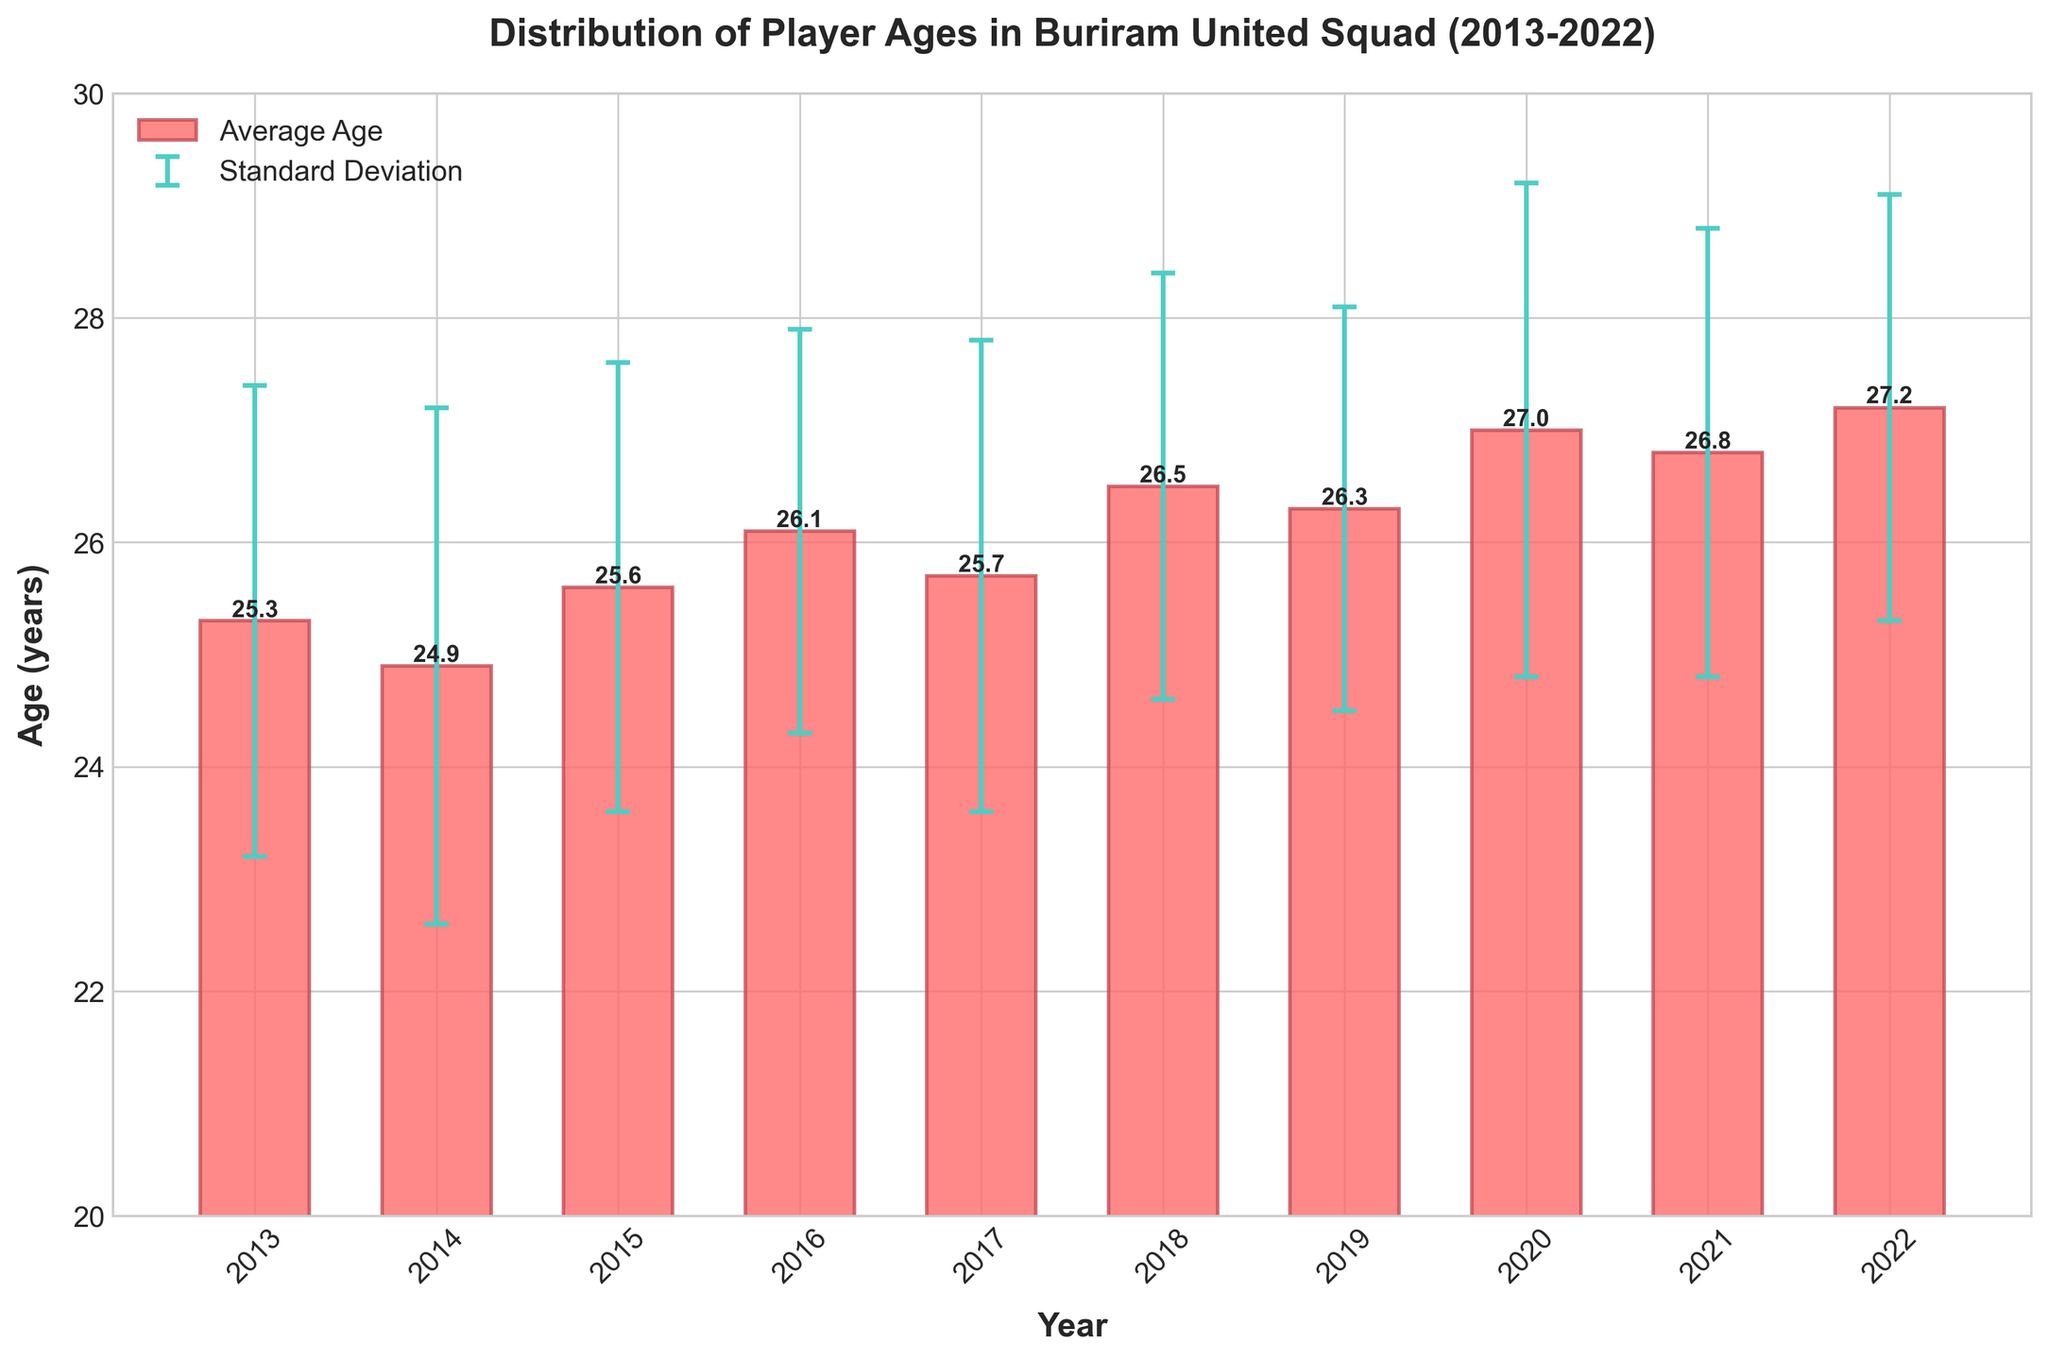what is the title of the chart? The title of the chart is usually located at the top of the figure. In this case, the title is "Distribution of Player Ages in Buriram United Squad (2013-2022)"
Answer: Distribution of Player Ages in Buriram United Squad (2013-2022) How many years are represented in the bar chart? To count the number of years, look at the x-axis labels. They range from 2013 to 2022, inclusive.
Answer: 10 What is the average age of players in 2017? Look for the bar corresponding to the year 2017. The height of the bar represents the average age, which is also labeled on top.
Answer: 25.7 During which year did the squad have the highest average age? Find the bar with the greatest height and look at which year it corresponds to. The highest bar is for 2022.
Answer: 2022 Which year shows the smallest standard deviation in player ages, and what is its value? The standard deviation is represented by the error bars. Look for the smallest error bar and identify the corresponding year and value. The smallest error bar is in 2019, with a value of 1.8.
Answer: 2019, 1.8 What is the difference between the average age in 2020 and 2013? Find the average ages for 2020 and 2013 from the bars and subtract the two values (27.0 - 25.3).
Answer: 1.7 Which year exhibits a higher average age, 2016 or 2018, and by how much? Compare the heights of the bars for 2016 and 2018. 2016 has an average age of 26.1, and 2018 has an average age of 26.5. The difference is 0.4.
Answer: 2018, by 0.4 Is the average age in 2015 closer to the average age in 2014 or 2016? Compare the differences (25.6 - 24.9 for 2014 and 26.1 - 25.6 for 2016). The difference between 2015 and 2014 is 0.7, and the difference between 2015 and 2016 is 0.5, making it closer to 2016.
Answer: 2016 What trend can you observe in the average player age from 2019 to 2022? Look at the heights of the bars for the years 2019 to 2022. The average age increases steadily: 26.3 (2019), 27.0 (2020), 26.8 (2021), 27.2 (2022).
Answer: Increasing trend If the average age and standard deviation in 2023 were to follow the trend from 2018 to 2022, what might they be? First, identify the trend for both the average age and standard deviation from 2018 to 2022. For the average age, it mostly increased: 26.5, 26.3, 27.0, 26.8, 27.2. If we follow this pattern, the average age might increase slightly, possibly around 27.5. The standard deviation has ranged between 1.8 and 2.2. Assuming a similar pattern, the standard deviation might be around 2.0.
Answer: Average age: ~27.5, Standard deviation: ~2.0 